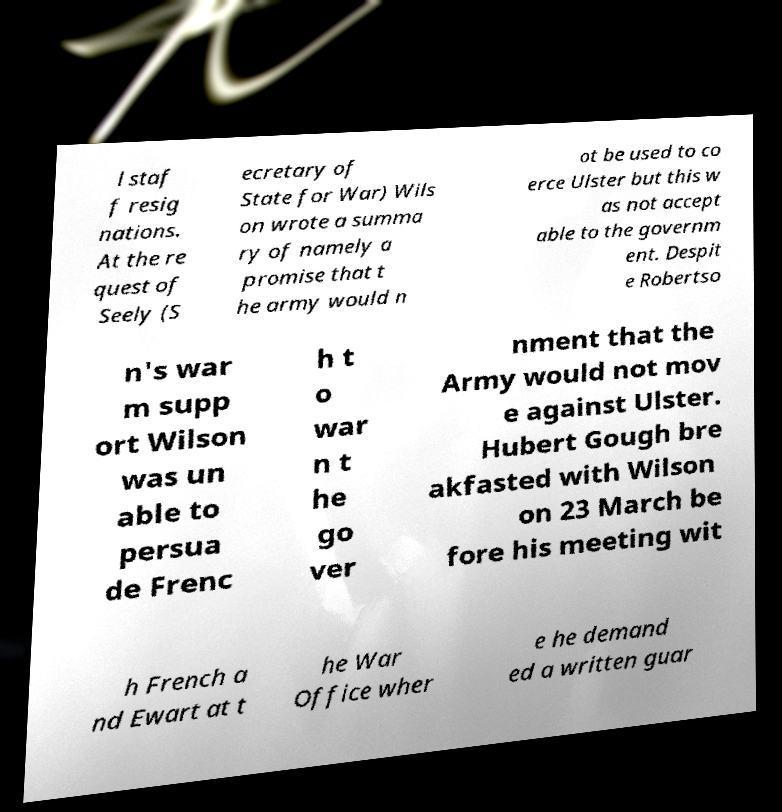Please read and relay the text visible in this image. What does it say? l staf f resig nations. At the re quest of Seely (S ecretary of State for War) Wils on wrote a summa ry of namely a promise that t he army would n ot be used to co erce Ulster but this w as not accept able to the governm ent. Despit e Robertso n's war m supp ort Wilson was un able to persua de Frenc h t o war n t he go ver nment that the Army would not mov e against Ulster. Hubert Gough bre akfasted with Wilson on 23 March be fore his meeting wit h French a nd Ewart at t he War Office wher e he demand ed a written guar 